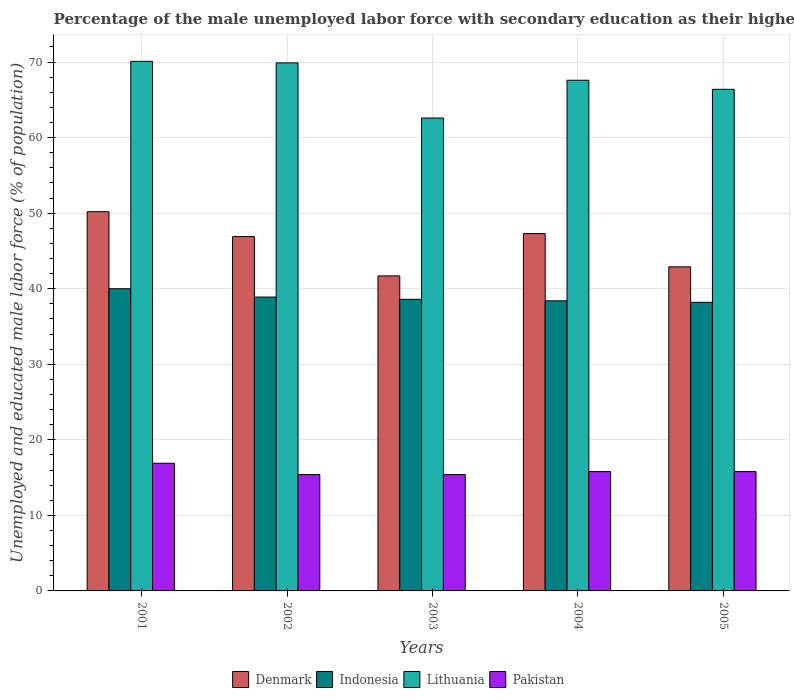How many different coloured bars are there?
Your response must be concise. 4. How many groups of bars are there?
Give a very brief answer. 5. Are the number of bars per tick equal to the number of legend labels?
Make the answer very short. Yes. Are the number of bars on each tick of the X-axis equal?
Ensure brevity in your answer.  Yes. How many bars are there on the 3rd tick from the left?
Your response must be concise. 4. How many bars are there on the 4th tick from the right?
Offer a terse response. 4. What is the label of the 1st group of bars from the left?
Provide a short and direct response. 2001. What is the percentage of the unemployed male labor force with secondary education in Pakistan in 2005?
Provide a succinct answer. 15.8. Across all years, what is the maximum percentage of the unemployed male labor force with secondary education in Lithuania?
Keep it short and to the point. 70.1. Across all years, what is the minimum percentage of the unemployed male labor force with secondary education in Indonesia?
Give a very brief answer. 38.2. What is the total percentage of the unemployed male labor force with secondary education in Pakistan in the graph?
Your response must be concise. 79.3. What is the difference between the percentage of the unemployed male labor force with secondary education in Lithuania in 2003 and that in 2005?
Your response must be concise. -3.8. What is the difference between the percentage of the unemployed male labor force with secondary education in Denmark in 2005 and the percentage of the unemployed male labor force with secondary education in Lithuania in 2002?
Provide a short and direct response. -27. What is the average percentage of the unemployed male labor force with secondary education in Pakistan per year?
Offer a very short reply. 15.86. In the year 2004, what is the difference between the percentage of the unemployed male labor force with secondary education in Denmark and percentage of the unemployed male labor force with secondary education in Indonesia?
Make the answer very short. 8.9. What is the ratio of the percentage of the unemployed male labor force with secondary education in Pakistan in 2002 to that in 2005?
Your response must be concise. 0.97. Is the difference between the percentage of the unemployed male labor force with secondary education in Denmark in 2002 and 2004 greater than the difference between the percentage of the unemployed male labor force with secondary education in Indonesia in 2002 and 2004?
Offer a terse response. No. What is the difference between the highest and the second highest percentage of the unemployed male labor force with secondary education in Indonesia?
Your answer should be compact. 1.1. In how many years, is the percentage of the unemployed male labor force with secondary education in Lithuania greater than the average percentage of the unemployed male labor force with secondary education in Lithuania taken over all years?
Ensure brevity in your answer.  3. Is it the case that in every year, the sum of the percentage of the unemployed male labor force with secondary education in Lithuania and percentage of the unemployed male labor force with secondary education in Indonesia is greater than the sum of percentage of the unemployed male labor force with secondary education in Denmark and percentage of the unemployed male labor force with secondary education in Pakistan?
Offer a very short reply. Yes. What does the 4th bar from the left in 2004 represents?
Offer a terse response. Pakistan. What does the 2nd bar from the right in 2005 represents?
Your response must be concise. Lithuania. How many bars are there?
Your response must be concise. 20. Are the values on the major ticks of Y-axis written in scientific E-notation?
Offer a terse response. No. Where does the legend appear in the graph?
Provide a short and direct response. Bottom center. How are the legend labels stacked?
Give a very brief answer. Horizontal. What is the title of the graph?
Your response must be concise. Percentage of the male unemployed labor force with secondary education as their highest grade. What is the label or title of the X-axis?
Your response must be concise. Years. What is the label or title of the Y-axis?
Offer a terse response. Unemployed and educated male labor force (% of population). What is the Unemployed and educated male labor force (% of population) in Denmark in 2001?
Your response must be concise. 50.2. What is the Unemployed and educated male labor force (% of population) in Indonesia in 2001?
Your response must be concise. 40. What is the Unemployed and educated male labor force (% of population) of Lithuania in 2001?
Offer a very short reply. 70.1. What is the Unemployed and educated male labor force (% of population) in Pakistan in 2001?
Give a very brief answer. 16.9. What is the Unemployed and educated male labor force (% of population) of Denmark in 2002?
Offer a terse response. 46.9. What is the Unemployed and educated male labor force (% of population) of Indonesia in 2002?
Your answer should be very brief. 38.9. What is the Unemployed and educated male labor force (% of population) of Lithuania in 2002?
Keep it short and to the point. 69.9. What is the Unemployed and educated male labor force (% of population) of Pakistan in 2002?
Provide a succinct answer. 15.4. What is the Unemployed and educated male labor force (% of population) of Denmark in 2003?
Keep it short and to the point. 41.7. What is the Unemployed and educated male labor force (% of population) of Indonesia in 2003?
Your response must be concise. 38.6. What is the Unemployed and educated male labor force (% of population) in Lithuania in 2003?
Make the answer very short. 62.6. What is the Unemployed and educated male labor force (% of population) in Pakistan in 2003?
Your answer should be very brief. 15.4. What is the Unemployed and educated male labor force (% of population) of Denmark in 2004?
Your response must be concise. 47.3. What is the Unemployed and educated male labor force (% of population) of Indonesia in 2004?
Keep it short and to the point. 38.4. What is the Unemployed and educated male labor force (% of population) in Lithuania in 2004?
Give a very brief answer. 67.6. What is the Unemployed and educated male labor force (% of population) of Pakistan in 2004?
Give a very brief answer. 15.8. What is the Unemployed and educated male labor force (% of population) of Denmark in 2005?
Offer a terse response. 42.9. What is the Unemployed and educated male labor force (% of population) in Indonesia in 2005?
Provide a short and direct response. 38.2. What is the Unemployed and educated male labor force (% of population) in Lithuania in 2005?
Your answer should be compact. 66.4. What is the Unemployed and educated male labor force (% of population) in Pakistan in 2005?
Offer a terse response. 15.8. Across all years, what is the maximum Unemployed and educated male labor force (% of population) of Denmark?
Offer a terse response. 50.2. Across all years, what is the maximum Unemployed and educated male labor force (% of population) in Lithuania?
Ensure brevity in your answer.  70.1. Across all years, what is the maximum Unemployed and educated male labor force (% of population) of Pakistan?
Offer a terse response. 16.9. Across all years, what is the minimum Unemployed and educated male labor force (% of population) in Denmark?
Provide a succinct answer. 41.7. Across all years, what is the minimum Unemployed and educated male labor force (% of population) of Indonesia?
Provide a succinct answer. 38.2. Across all years, what is the minimum Unemployed and educated male labor force (% of population) in Lithuania?
Your answer should be very brief. 62.6. Across all years, what is the minimum Unemployed and educated male labor force (% of population) of Pakistan?
Provide a short and direct response. 15.4. What is the total Unemployed and educated male labor force (% of population) of Denmark in the graph?
Keep it short and to the point. 229. What is the total Unemployed and educated male labor force (% of population) of Indonesia in the graph?
Provide a short and direct response. 194.1. What is the total Unemployed and educated male labor force (% of population) of Lithuania in the graph?
Provide a short and direct response. 336.6. What is the total Unemployed and educated male labor force (% of population) in Pakistan in the graph?
Offer a very short reply. 79.3. What is the difference between the Unemployed and educated male labor force (% of population) in Indonesia in 2001 and that in 2002?
Provide a succinct answer. 1.1. What is the difference between the Unemployed and educated male labor force (% of population) in Pakistan in 2001 and that in 2002?
Ensure brevity in your answer.  1.5. What is the difference between the Unemployed and educated male labor force (% of population) of Lithuania in 2001 and that in 2003?
Make the answer very short. 7.5. What is the difference between the Unemployed and educated male labor force (% of population) in Indonesia in 2001 and that in 2004?
Your answer should be compact. 1.6. What is the difference between the Unemployed and educated male labor force (% of population) of Lithuania in 2001 and that in 2004?
Ensure brevity in your answer.  2.5. What is the difference between the Unemployed and educated male labor force (% of population) of Pakistan in 2001 and that in 2004?
Your response must be concise. 1.1. What is the difference between the Unemployed and educated male labor force (% of population) of Denmark in 2001 and that in 2005?
Provide a succinct answer. 7.3. What is the difference between the Unemployed and educated male labor force (% of population) of Indonesia in 2001 and that in 2005?
Provide a short and direct response. 1.8. What is the difference between the Unemployed and educated male labor force (% of population) in Lithuania in 2001 and that in 2005?
Offer a terse response. 3.7. What is the difference between the Unemployed and educated male labor force (% of population) of Denmark in 2002 and that in 2003?
Ensure brevity in your answer.  5.2. What is the difference between the Unemployed and educated male labor force (% of population) in Pakistan in 2002 and that in 2003?
Your response must be concise. 0. What is the difference between the Unemployed and educated male labor force (% of population) of Indonesia in 2002 and that in 2004?
Provide a succinct answer. 0.5. What is the difference between the Unemployed and educated male labor force (% of population) of Lithuania in 2002 and that in 2004?
Ensure brevity in your answer.  2.3. What is the difference between the Unemployed and educated male labor force (% of population) in Lithuania in 2002 and that in 2005?
Offer a terse response. 3.5. What is the difference between the Unemployed and educated male labor force (% of population) in Denmark in 2003 and that in 2004?
Ensure brevity in your answer.  -5.6. What is the difference between the Unemployed and educated male labor force (% of population) of Lithuania in 2003 and that in 2004?
Your answer should be compact. -5. What is the difference between the Unemployed and educated male labor force (% of population) of Denmark in 2003 and that in 2005?
Your answer should be very brief. -1.2. What is the difference between the Unemployed and educated male labor force (% of population) of Pakistan in 2003 and that in 2005?
Provide a short and direct response. -0.4. What is the difference between the Unemployed and educated male labor force (% of population) in Indonesia in 2004 and that in 2005?
Offer a terse response. 0.2. What is the difference between the Unemployed and educated male labor force (% of population) in Lithuania in 2004 and that in 2005?
Your response must be concise. 1.2. What is the difference between the Unemployed and educated male labor force (% of population) of Denmark in 2001 and the Unemployed and educated male labor force (% of population) of Lithuania in 2002?
Offer a very short reply. -19.7. What is the difference between the Unemployed and educated male labor force (% of population) in Denmark in 2001 and the Unemployed and educated male labor force (% of population) in Pakistan in 2002?
Ensure brevity in your answer.  34.8. What is the difference between the Unemployed and educated male labor force (% of population) of Indonesia in 2001 and the Unemployed and educated male labor force (% of population) of Lithuania in 2002?
Ensure brevity in your answer.  -29.9. What is the difference between the Unemployed and educated male labor force (% of population) of Indonesia in 2001 and the Unemployed and educated male labor force (% of population) of Pakistan in 2002?
Provide a short and direct response. 24.6. What is the difference between the Unemployed and educated male labor force (% of population) in Lithuania in 2001 and the Unemployed and educated male labor force (% of population) in Pakistan in 2002?
Offer a terse response. 54.7. What is the difference between the Unemployed and educated male labor force (% of population) in Denmark in 2001 and the Unemployed and educated male labor force (% of population) in Pakistan in 2003?
Provide a succinct answer. 34.8. What is the difference between the Unemployed and educated male labor force (% of population) in Indonesia in 2001 and the Unemployed and educated male labor force (% of population) in Lithuania in 2003?
Offer a very short reply. -22.6. What is the difference between the Unemployed and educated male labor force (% of population) in Indonesia in 2001 and the Unemployed and educated male labor force (% of population) in Pakistan in 2003?
Offer a terse response. 24.6. What is the difference between the Unemployed and educated male labor force (% of population) in Lithuania in 2001 and the Unemployed and educated male labor force (% of population) in Pakistan in 2003?
Your response must be concise. 54.7. What is the difference between the Unemployed and educated male labor force (% of population) in Denmark in 2001 and the Unemployed and educated male labor force (% of population) in Lithuania in 2004?
Provide a succinct answer. -17.4. What is the difference between the Unemployed and educated male labor force (% of population) of Denmark in 2001 and the Unemployed and educated male labor force (% of population) of Pakistan in 2004?
Keep it short and to the point. 34.4. What is the difference between the Unemployed and educated male labor force (% of population) of Indonesia in 2001 and the Unemployed and educated male labor force (% of population) of Lithuania in 2004?
Keep it short and to the point. -27.6. What is the difference between the Unemployed and educated male labor force (% of population) in Indonesia in 2001 and the Unemployed and educated male labor force (% of population) in Pakistan in 2004?
Offer a very short reply. 24.2. What is the difference between the Unemployed and educated male labor force (% of population) of Lithuania in 2001 and the Unemployed and educated male labor force (% of population) of Pakistan in 2004?
Ensure brevity in your answer.  54.3. What is the difference between the Unemployed and educated male labor force (% of population) of Denmark in 2001 and the Unemployed and educated male labor force (% of population) of Lithuania in 2005?
Offer a terse response. -16.2. What is the difference between the Unemployed and educated male labor force (% of population) of Denmark in 2001 and the Unemployed and educated male labor force (% of population) of Pakistan in 2005?
Ensure brevity in your answer.  34.4. What is the difference between the Unemployed and educated male labor force (% of population) of Indonesia in 2001 and the Unemployed and educated male labor force (% of population) of Lithuania in 2005?
Offer a terse response. -26.4. What is the difference between the Unemployed and educated male labor force (% of population) in Indonesia in 2001 and the Unemployed and educated male labor force (% of population) in Pakistan in 2005?
Provide a succinct answer. 24.2. What is the difference between the Unemployed and educated male labor force (% of population) in Lithuania in 2001 and the Unemployed and educated male labor force (% of population) in Pakistan in 2005?
Your response must be concise. 54.3. What is the difference between the Unemployed and educated male labor force (% of population) of Denmark in 2002 and the Unemployed and educated male labor force (% of population) of Indonesia in 2003?
Offer a very short reply. 8.3. What is the difference between the Unemployed and educated male labor force (% of population) of Denmark in 2002 and the Unemployed and educated male labor force (% of population) of Lithuania in 2003?
Ensure brevity in your answer.  -15.7. What is the difference between the Unemployed and educated male labor force (% of population) in Denmark in 2002 and the Unemployed and educated male labor force (% of population) in Pakistan in 2003?
Make the answer very short. 31.5. What is the difference between the Unemployed and educated male labor force (% of population) in Indonesia in 2002 and the Unemployed and educated male labor force (% of population) in Lithuania in 2003?
Give a very brief answer. -23.7. What is the difference between the Unemployed and educated male labor force (% of population) of Lithuania in 2002 and the Unemployed and educated male labor force (% of population) of Pakistan in 2003?
Keep it short and to the point. 54.5. What is the difference between the Unemployed and educated male labor force (% of population) in Denmark in 2002 and the Unemployed and educated male labor force (% of population) in Indonesia in 2004?
Offer a very short reply. 8.5. What is the difference between the Unemployed and educated male labor force (% of population) of Denmark in 2002 and the Unemployed and educated male labor force (% of population) of Lithuania in 2004?
Offer a terse response. -20.7. What is the difference between the Unemployed and educated male labor force (% of population) in Denmark in 2002 and the Unemployed and educated male labor force (% of population) in Pakistan in 2004?
Give a very brief answer. 31.1. What is the difference between the Unemployed and educated male labor force (% of population) of Indonesia in 2002 and the Unemployed and educated male labor force (% of population) of Lithuania in 2004?
Your response must be concise. -28.7. What is the difference between the Unemployed and educated male labor force (% of population) in Indonesia in 2002 and the Unemployed and educated male labor force (% of population) in Pakistan in 2004?
Your answer should be compact. 23.1. What is the difference between the Unemployed and educated male labor force (% of population) in Lithuania in 2002 and the Unemployed and educated male labor force (% of population) in Pakistan in 2004?
Keep it short and to the point. 54.1. What is the difference between the Unemployed and educated male labor force (% of population) of Denmark in 2002 and the Unemployed and educated male labor force (% of population) of Lithuania in 2005?
Give a very brief answer. -19.5. What is the difference between the Unemployed and educated male labor force (% of population) in Denmark in 2002 and the Unemployed and educated male labor force (% of population) in Pakistan in 2005?
Offer a terse response. 31.1. What is the difference between the Unemployed and educated male labor force (% of population) of Indonesia in 2002 and the Unemployed and educated male labor force (% of population) of Lithuania in 2005?
Provide a succinct answer. -27.5. What is the difference between the Unemployed and educated male labor force (% of population) in Indonesia in 2002 and the Unemployed and educated male labor force (% of population) in Pakistan in 2005?
Your answer should be compact. 23.1. What is the difference between the Unemployed and educated male labor force (% of population) in Lithuania in 2002 and the Unemployed and educated male labor force (% of population) in Pakistan in 2005?
Offer a very short reply. 54.1. What is the difference between the Unemployed and educated male labor force (% of population) in Denmark in 2003 and the Unemployed and educated male labor force (% of population) in Lithuania in 2004?
Your answer should be very brief. -25.9. What is the difference between the Unemployed and educated male labor force (% of population) of Denmark in 2003 and the Unemployed and educated male labor force (% of population) of Pakistan in 2004?
Provide a short and direct response. 25.9. What is the difference between the Unemployed and educated male labor force (% of population) in Indonesia in 2003 and the Unemployed and educated male labor force (% of population) in Pakistan in 2004?
Offer a very short reply. 22.8. What is the difference between the Unemployed and educated male labor force (% of population) in Lithuania in 2003 and the Unemployed and educated male labor force (% of population) in Pakistan in 2004?
Ensure brevity in your answer.  46.8. What is the difference between the Unemployed and educated male labor force (% of population) in Denmark in 2003 and the Unemployed and educated male labor force (% of population) in Indonesia in 2005?
Provide a short and direct response. 3.5. What is the difference between the Unemployed and educated male labor force (% of population) of Denmark in 2003 and the Unemployed and educated male labor force (% of population) of Lithuania in 2005?
Your answer should be very brief. -24.7. What is the difference between the Unemployed and educated male labor force (% of population) of Denmark in 2003 and the Unemployed and educated male labor force (% of population) of Pakistan in 2005?
Offer a very short reply. 25.9. What is the difference between the Unemployed and educated male labor force (% of population) in Indonesia in 2003 and the Unemployed and educated male labor force (% of population) in Lithuania in 2005?
Offer a terse response. -27.8. What is the difference between the Unemployed and educated male labor force (% of population) in Indonesia in 2003 and the Unemployed and educated male labor force (% of population) in Pakistan in 2005?
Your answer should be very brief. 22.8. What is the difference between the Unemployed and educated male labor force (% of population) in Lithuania in 2003 and the Unemployed and educated male labor force (% of population) in Pakistan in 2005?
Make the answer very short. 46.8. What is the difference between the Unemployed and educated male labor force (% of population) of Denmark in 2004 and the Unemployed and educated male labor force (% of population) of Lithuania in 2005?
Provide a short and direct response. -19.1. What is the difference between the Unemployed and educated male labor force (% of population) in Denmark in 2004 and the Unemployed and educated male labor force (% of population) in Pakistan in 2005?
Provide a short and direct response. 31.5. What is the difference between the Unemployed and educated male labor force (% of population) of Indonesia in 2004 and the Unemployed and educated male labor force (% of population) of Pakistan in 2005?
Provide a succinct answer. 22.6. What is the difference between the Unemployed and educated male labor force (% of population) in Lithuania in 2004 and the Unemployed and educated male labor force (% of population) in Pakistan in 2005?
Ensure brevity in your answer.  51.8. What is the average Unemployed and educated male labor force (% of population) in Denmark per year?
Give a very brief answer. 45.8. What is the average Unemployed and educated male labor force (% of population) of Indonesia per year?
Offer a very short reply. 38.82. What is the average Unemployed and educated male labor force (% of population) in Lithuania per year?
Make the answer very short. 67.32. What is the average Unemployed and educated male labor force (% of population) of Pakistan per year?
Your response must be concise. 15.86. In the year 2001, what is the difference between the Unemployed and educated male labor force (% of population) of Denmark and Unemployed and educated male labor force (% of population) of Lithuania?
Your answer should be very brief. -19.9. In the year 2001, what is the difference between the Unemployed and educated male labor force (% of population) of Denmark and Unemployed and educated male labor force (% of population) of Pakistan?
Give a very brief answer. 33.3. In the year 2001, what is the difference between the Unemployed and educated male labor force (% of population) in Indonesia and Unemployed and educated male labor force (% of population) in Lithuania?
Provide a short and direct response. -30.1. In the year 2001, what is the difference between the Unemployed and educated male labor force (% of population) of Indonesia and Unemployed and educated male labor force (% of population) of Pakistan?
Ensure brevity in your answer.  23.1. In the year 2001, what is the difference between the Unemployed and educated male labor force (% of population) in Lithuania and Unemployed and educated male labor force (% of population) in Pakistan?
Your answer should be compact. 53.2. In the year 2002, what is the difference between the Unemployed and educated male labor force (% of population) of Denmark and Unemployed and educated male labor force (% of population) of Indonesia?
Offer a terse response. 8. In the year 2002, what is the difference between the Unemployed and educated male labor force (% of population) in Denmark and Unemployed and educated male labor force (% of population) in Lithuania?
Give a very brief answer. -23. In the year 2002, what is the difference between the Unemployed and educated male labor force (% of population) in Denmark and Unemployed and educated male labor force (% of population) in Pakistan?
Provide a short and direct response. 31.5. In the year 2002, what is the difference between the Unemployed and educated male labor force (% of population) of Indonesia and Unemployed and educated male labor force (% of population) of Lithuania?
Provide a short and direct response. -31. In the year 2002, what is the difference between the Unemployed and educated male labor force (% of population) in Indonesia and Unemployed and educated male labor force (% of population) in Pakistan?
Your answer should be very brief. 23.5. In the year 2002, what is the difference between the Unemployed and educated male labor force (% of population) in Lithuania and Unemployed and educated male labor force (% of population) in Pakistan?
Offer a terse response. 54.5. In the year 2003, what is the difference between the Unemployed and educated male labor force (% of population) in Denmark and Unemployed and educated male labor force (% of population) in Lithuania?
Your answer should be compact. -20.9. In the year 2003, what is the difference between the Unemployed and educated male labor force (% of population) of Denmark and Unemployed and educated male labor force (% of population) of Pakistan?
Keep it short and to the point. 26.3. In the year 2003, what is the difference between the Unemployed and educated male labor force (% of population) in Indonesia and Unemployed and educated male labor force (% of population) in Lithuania?
Provide a succinct answer. -24. In the year 2003, what is the difference between the Unemployed and educated male labor force (% of population) in Indonesia and Unemployed and educated male labor force (% of population) in Pakistan?
Provide a short and direct response. 23.2. In the year 2003, what is the difference between the Unemployed and educated male labor force (% of population) of Lithuania and Unemployed and educated male labor force (% of population) of Pakistan?
Your answer should be compact. 47.2. In the year 2004, what is the difference between the Unemployed and educated male labor force (% of population) of Denmark and Unemployed and educated male labor force (% of population) of Indonesia?
Your answer should be very brief. 8.9. In the year 2004, what is the difference between the Unemployed and educated male labor force (% of population) of Denmark and Unemployed and educated male labor force (% of population) of Lithuania?
Your response must be concise. -20.3. In the year 2004, what is the difference between the Unemployed and educated male labor force (% of population) of Denmark and Unemployed and educated male labor force (% of population) of Pakistan?
Make the answer very short. 31.5. In the year 2004, what is the difference between the Unemployed and educated male labor force (% of population) of Indonesia and Unemployed and educated male labor force (% of population) of Lithuania?
Provide a short and direct response. -29.2. In the year 2004, what is the difference between the Unemployed and educated male labor force (% of population) in Indonesia and Unemployed and educated male labor force (% of population) in Pakistan?
Offer a very short reply. 22.6. In the year 2004, what is the difference between the Unemployed and educated male labor force (% of population) in Lithuania and Unemployed and educated male labor force (% of population) in Pakistan?
Ensure brevity in your answer.  51.8. In the year 2005, what is the difference between the Unemployed and educated male labor force (% of population) in Denmark and Unemployed and educated male labor force (% of population) in Indonesia?
Your response must be concise. 4.7. In the year 2005, what is the difference between the Unemployed and educated male labor force (% of population) of Denmark and Unemployed and educated male labor force (% of population) of Lithuania?
Keep it short and to the point. -23.5. In the year 2005, what is the difference between the Unemployed and educated male labor force (% of population) in Denmark and Unemployed and educated male labor force (% of population) in Pakistan?
Give a very brief answer. 27.1. In the year 2005, what is the difference between the Unemployed and educated male labor force (% of population) in Indonesia and Unemployed and educated male labor force (% of population) in Lithuania?
Keep it short and to the point. -28.2. In the year 2005, what is the difference between the Unemployed and educated male labor force (% of population) in Indonesia and Unemployed and educated male labor force (% of population) in Pakistan?
Keep it short and to the point. 22.4. In the year 2005, what is the difference between the Unemployed and educated male labor force (% of population) of Lithuania and Unemployed and educated male labor force (% of population) of Pakistan?
Keep it short and to the point. 50.6. What is the ratio of the Unemployed and educated male labor force (% of population) of Denmark in 2001 to that in 2002?
Ensure brevity in your answer.  1.07. What is the ratio of the Unemployed and educated male labor force (% of population) of Indonesia in 2001 to that in 2002?
Provide a short and direct response. 1.03. What is the ratio of the Unemployed and educated male labor force (% of population) in Lithuania in 2001 to that in 2002?
Keep it short and to the point. 1. What is the ratio of the Unemployed and educated male labor force (% of population) in Pakistan in 2001 to that in 2002?
Provide a short and direct response. 1.1. What is the ratio of the Unemployed and educated male labor force (% of population) in Denmark in 2001 to that in 2003?
Your answer should be very brief. 1.2. What is the ratio of the Unemployed and educated male labor force (% of population) of Indonesia in 2001 to that in 2003?
Offer a terse response. 1.04. What is the ratio of the Unemployed and educated male labor force (% of population) in Lithuania in 2001 to that in 2003?
Make the answer very short. 1.12. What is the ratio of the Unemployed and educated male labor force (% of population) in Pakistan in 2001 to that in 2003?
Your answer should be very brief. 1.1. What is the ratio of the Unemployed and educated male labor force (% of population) in Denmark in 2001 to that in 2004?
Keep it short and to the point. 1.06. What is the ratio of the Unemployed and educated male labor force (% of population) in Indonesia in 2001 to that in 2004?
Your response must be concise. 1.04. What is the ratio of the Unemployed and educated male labor force (% of population) of Pakistan in 2001 to that in 2004?
Ensure brevity in your answer.  1.07. What is the ratio of the Unemployed and educated male labor force (% of population) in Denmark in 2001 to that in 2005?
Keep it short and to the point. 1.17. What is the ratio of the Unemployed and educated male labor force (% of population) of Indonesia in 2001 to that in 2005?
Ensure brevity in your answer.  1.05. What is the ratio of the Unemployed and educated male labor force (% of population) of Lithuania in 2001 to that in 2005?
Make the answer very short. 1.06. What is the ratio of the Unemployed and educated male labor force (% of population) of Pakistan in 2001 to that in 2005?
Offer a very short reply. 1.07. What is the ratio of the Unemployed and educated male labor force (% of population) in Denmark in 2002 to that in 2003?
Ensure brevity in your answer.  1.12. What is the ratio of the Unemployed and educated male labor force (% of population) of Indonesia in 2002 to that in 2003?
Offer a terse response. 1.01. What is the ratio of the Unemployed and educated male labor force (% of population) in Lithuania in 2002 to that in 2003?
Provide a short and direct response. 1.12. What is the ratio of the Unemployed and educated male labor force (% of population) in Pakistan in 2002 to that in 2003?
Your answer should be compact. 1. What is the ratio of the Unemployed and educated male labor force (% of population) in Denmark in 2002 to that in 2004?
Offer a terse response. 0.99. What is the ratio of the Unemployed and educated male labor force (% of population) of Indonesia in 2002 to that in 2004?
Ensure brevity in your answer.  1.01. What is the ratio of the Unemployed and educated male labor force (% of population) in Lithuania in 2002 to that in 2004?
Your response must be concise. 1.03. What is the ratio of the Unemployed and educated male labor force (% of population) of Pakistan in 2002 to that in 2004?
Offer a very short reply. 0.97. What is the ratio of the Unemployed and educated male labor force (% of population) of Denmark in 2002 to that in 2005?
Your response must be concise. 1.09. What is the ratio of the Unemployed and educated male labor force (% of population) of Indonesia in 2002 to that in 2005?
Provide a succinct answer. 1.02. What is the ratio of the Unemployed and educated male labor force (% of population) in Lithuania in 2002 to that in 2005?
Provide a short and direct response. 1.05. What is the ratio of the Unemployed and educated male labor force (% of population) in Pakistan in 2002 to that in 2005?
Offer a terse response. 0.97. What is the ratio of the Unemployed and educated male labor force (% of population) in Denmark in 2003 to that in 2004?
Make the answer very short. 0.88. What is the ratio of the Unemployed and educated male labor force (% of population) in Lithuania in 2003 to that in 2004?
Provide a succinct answer. 0.93. What is the ratio of the Unemployed and educated male labor force (% of population) in Pakistan in 2003 to that in 2004?
Provide a succinct answer. 0.97. What is the ratio of the Unemployed and educated male labor force (% of population) in Denmark in 2003 to that in 2005?
Offer a very short reply. 0.97. What is the ratio of the Unemployed and educated male labor force (% of population) of Indonesia in 2003 to that in 2005?
Offer a terse response. 1.01. What is the ratio of the Unemployed and educated male labor force (% of population) of Lithuania in 2003 to that in 2005?
Make the answer very short. 0.94. What is the ratio of the Unemployed and educated male labor force (% of population) of Pakistan in 2003 to that in 2005?
Your response must be concise. 0.97. What is the ratio of the Unemployed and educated male labor force (% of population) of Denmark in 2004 to that in 2005?
Keep it short and to the point. 1.1. What is the ratio of the Unemployed and educated male labor force (% of population) in Lithuania in 2004 to that in 2005?
Offer a terse response. 1.02. What is the ratio of the Unemployed and educated male labor force (% of population) of Pakistan in 2004 to that in 2005?
Make the answer very short. 1. What is the difference between the highest and the lowest Unemployed and educated male labor force (% of population) in Denmark?
Your answer should be compact. 8.5. What is the difference between the highest and the lowest Unemployed and educated male labor force (% of population) in Indonesia?
Keep it short and to the point. 1.8. What is the difference between the highest and the lowest Unemployed and educated male labor force (% of population) in Pakistan?
Make the answer very short. 1.5. 